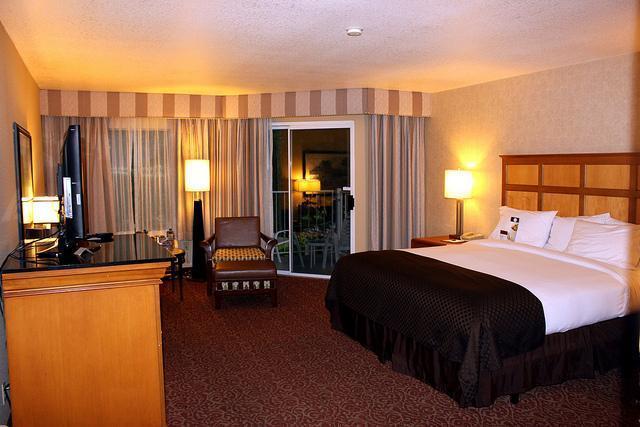How many tvs are in the picture?
Give a very brief answer. 2. How many birds are there?
Give a very brief answer. 0. 